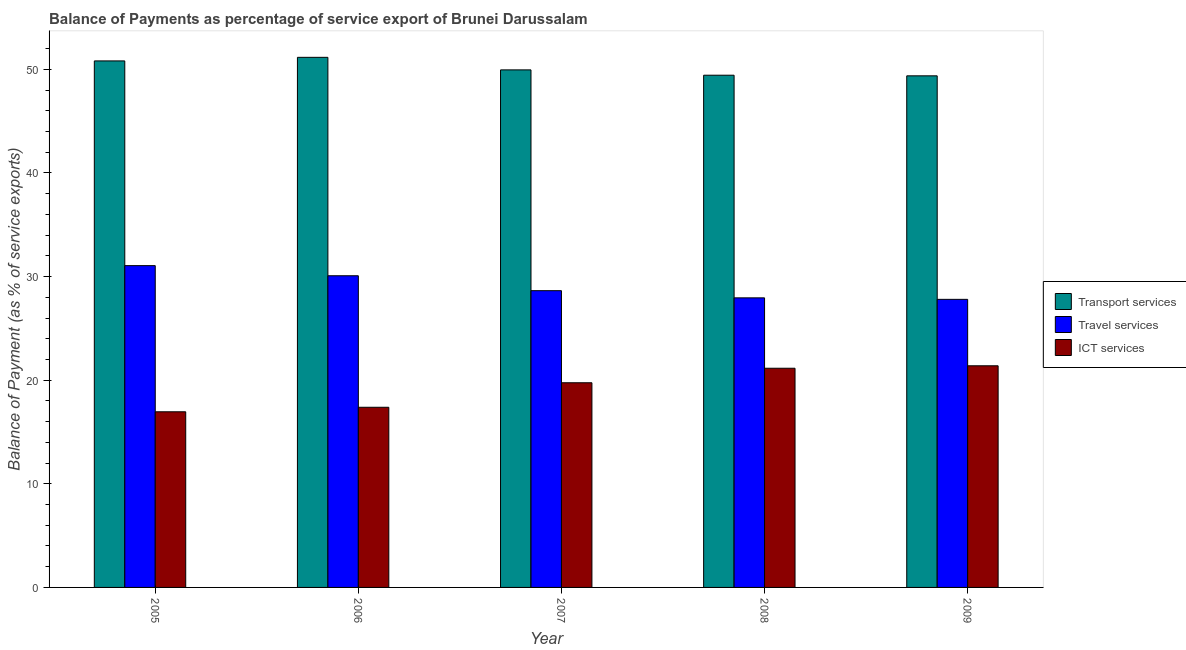Are the number of bars on each tick of the X-axis equal?
Provide a succinct answer. Yes. How many bars are there on the 4th tick from the left?
Make the answer very short. 3. How many bars are there on the 1st tick from the right?
Offer a very short reply. 3. What is the balance of payment of transport services in 2005?
Provide a short and direct response. 50.81. Across all years, what is the maximum balance of payment of travel services?
Offer a very short reply. 31.06. Across all years, what is the minimum balance of payment of travel services?
Provide a succinct answer. 27.8. What is the total balance of payment of ict services in the graph?
Your response must be concise. 96.64. What is the difference between the balance of payment of travel services in 2005 and that in 2007?
Ensure brevity in your answer.  2.42. What is the difference between the balance of payment of transport services in 2009 and the balance of payment of travel services in 2005?
Provide a short and direct response. -1.44. What is the average balance of payment of travel services per year?
Your response must be concise. 29.11. In the year 2005, what is the difference between the balance of payment of travel services and balance of payment of transport services?
Ensure brevity in your answer.  0. In how many years, is the balance of payment of travel services greater than 44 %?
Your answer should be compact. 0. What is the ratio of the balance of payment of ict services in 2005 to that in 2006?
Keep it short and to the point. 0.97. Is the balance of payment of ict services in 2005 less than that in 2008?
Your answer should be compact. Yes. Is the difference between the balance of payment of ict services in 2005 and 2006 greater than the difference between the balance of payment of transport services in 2005 and 2006?
Keep it short and to the point. No. What is the difference between the highest and the second highest balance of payment of travel services?
Keep it short and to the point. 0.98. What is the difference between the highest and the lowest balance of payment of travel services?
Make the answer very short. 3.25. What does the 1st bar from the left in 2005 represents?
Your answer should be very brief. Transport services. What does the 1st bar from the right in 2009 represents?
Your answer should be compact. ICT services. How many bars are there?
Your response must be concise. 15. What is the difference between two consecutive major ticks on the Y-axis?
Provide a succinct answer. 10. Where does the legend appear in the graph?
Offer a very short reply. Center right. How many legend labels are there?
Make the answer very short. 3. What is the title of the graph?
Your response must be concise. Balance of Payments as percentage of service export of Brunei Darussalam. Does "Natural Gas" appear as one of the legend labels in the graph?
Give a very brief answer. No. What is the label or title of the Y-axis?
Your answer should be compact. Balance of Payment (as % of service exports). What is the Balance of Payment (as % of service exports) in Transport services in 2005?
Your answer should be very brief. 50.81. What is the Balance of Payment (as % of service exports) of Travel services in 2005?
Offer a very short reply. 31.06. What is the Balance of Payment (as % of service exports) in ICT services in 2005?
Give a very brief answer. 16.95. What is the Balance of Payment (as % of service exports) of Transport services in 2006?
Provide a succinct answer. 51.16. What is the Balance of Payment (as % of service exports) of Travel services in 2006?
Your answer should be compact. 30.08. What is the Balance of Payment (as % of service exports) of ICT services in 2006?
Your answer should be compact. 17.39. What is the Balance of Payment (as % of service exports) in Transport services in 2007?
Your response must be concise. 49.95. What is the Balance of Payment (as % of service exports) in Travel services in 2007?
Make the answer very short. 28.64. What is the Balance of Payment (as % of service exports) of ICT services in 2007?
Give a very brief answer. 19.75. What is the Balance of Payment (as % of service exports) of Transport services in 2008?
Provide a succinct answer. 49.44. What is the Balance of Payment (as % of service exports) of Travel services in 2008?
Your answer should be very brief. 27.95. What is the Balance of Payment (as % of service exports) in ICT services in 2008?
Your answer should be compact. 21.15. What is the Balance of Payment (as % of service exports) in Transport services in 2009?
Your answer should be very brief. 49.38. What is the Balance of Payment (as % of service exports) of Travel services in 2009?
Offer a terse response. 27.8. What is the Balance of Payment (as % of service exports) of ICT services in 2009?
Give a very brief answer. 21.39. Across all years, what is the maximum Balance of Payment (as % of service exports) of Transport services?
Offer a very short reply. 51.16. Across all years, what is the maximum Balance of Payment (as % of service exports) of Travel services?
Make the answer very short. 31.06. Across all years, what is the maximum Balance of Payment (as % of service exports) of ICT services?
Offer a very short reply. 21.39. Across all years, what is the minimum Balance of Payment (as % of service exports) of Transport services?
Keep it short and to the point. 49.38. Across all years, what is the minimum Balance of Payment (as % of service exports) of Travel services?
Offer a very short reply. 27.8. Across all years, what is the minimum Balance of Payment (as % of service exports) of ICT services?
Ensure brevity in your answer.  16.95. What is the total Balance of Payment (as % of service exports) of Transport services in the graph?
Your answer should be very brief. 250.74. What is the total Balance of Payment (as % of service exports) of Travel services in the graph?
Provide a succinct answer. 145.53. What is the total Balance of Payment (as % of service exports) of ICT services in the graph?
Make the answer very short. 96.64. What is the difference between the Balance of Payment (as % of service exports) of Transport services in 2005 and that in 2006?
Offer a terse response. -0.35. What is the difference between the Balance of Payment (as % of service exports) of Travel services in 2005 and that in 2006?
Provide a succinct answer. 0.98. What is the difference between the Balance of Payment (as % of service exports) in ICT services in 2005 and that in 2006?
Provide a succinct answer. -0.44. What is the difference between the Balance of Payment (as % of service exports) in Transport services in 2005 and that in 2007?
Ensure brevity in your answer.  0.86. What is the difference between the Balance of Payment (as % of service exports) of Travel services in 2005 and that in 2007?
Provide a short and direct response. 2.42. What is the difference between the Balance of Payment (as % of service exports) in ICT services in 2005 and that in 2007?
Offer a very short reply. -2.8. What is the difference between the Balance of Payment (as % of service exports) in Transport services in 2005 and that in 2008?
Keep it short and to the point. 1.38. What is the difference between the Balance of Payment (as % of service exports) in Travel services in 2005 and that in 2008?
Offer a terse response. 3.11. What is the difference between the Balance of Payment (as % of service exports) of ICT services in 2005 and that in 2008?
Your answer should be very brief. -4.2. What is the difference between the Balance of Payment (as % of service exports) in Transport services in 2005 and that in 2009?
Provide a short and direct response. 1.44. What is the difference between the Balance of Payment (as % of service exports) in Travel services in 2005 and that in 2009?
Provide a short and direct response. 3.25. What is the difference between the Balance of Payment (as % of service exports) in ICT services in 2005 and that in 2009?
Your answer should be very brief. -4.44. What is the difference between the Balance of Payment (as % of service exports) in Transport services in 2006 and that in 2007?
Your answer should be compact. 1.21. What is the difference between the Balance of Payment (as % of service exports) in Travel services in 2006 and that in 2007?
Offer a terse response. 1.44. What is the difference between the Balance of Payment (as % of service exports) of ICT services in 2006 and that in 2007?
Your answer should be very brief. -2.37. What is the difference between the Balance of Payment (as % of service exports) in Transport services in 2006 and that in 2008?
Make the answer very short. 1.73. What is the difference between the Balance of Payment (as % of service exports) in Travel services in 2006 and that in 2008?
Ensure brevity in your answer.  2.13. What is the difference between the Balance of Payment (as % of service exports) of ICT services in 2006 and that in 2008?
Your answer should be very brief. -3.77. What is the difference between the Balance of Payment (as % of service exports) of Transport services in 2006 and that in 2009?
Provide a short and direct response. 1.79. What is the difference between the Balance of Payment (as % of service exports) in Travel services in 2006 and that in 2009?
Give a very brief answer. 2.28. What is the difference between the Balance of Payment (as % of service exports) in ICT services in 2006 and that in 2009?
Your response must be concise. -4. What is the difference between the Balance of Payment (as % of service exports) in Transport services in 2007 and that in 2008?
Provide a short and direct response. 0.51. What is the difference between the Balance of Payment (as % of service exports) of Travel services in 2007 and that in 2008?
Your answer should be very brief. 0.69. What is the difference between the Balance of Payment (as % of service exports) in ICT services in 2007 and that in 2008?
Offer a very short reply. -1.4. What is the difference between the Balance of Payment (as % of service exports) of Transport services in 2007 and that in 2009?
Give a very brief answer. 0.57. What is the difference between the Balance of Payment (as % of service exports) in Travel services in 2007 and that in 2009?
Provide a short and direct response. 0.84. What is the difference between the Balance of Payment (as % of service exports) in ICT services in 2007 and that in 2009?
Provide a succinct answer. -1.64. What is the difference between the Balance of Payment (as % of service exports) of Transport services in 2008 and that in 2009?
Give a very brief answer. 0.06. What is the difference between the Balance of Payment (as % of service exports) of Travel services in 2008 and that in 2009?
Offer a very short reply. 0.14. What is the difference between the Balance of Payment (as % of service exports) of ICT services in 2008 and that in 2009?
Offer a very short reply. -0.24. What is the difference between the Balance of Payment (as % of service exports) of Transport services in 2005 and the Balance of Payment (as % of service exports) of Travel services in 2006?
Ensure brevity in your answer.  20.73. What is the difference between the Balance of Payment (as % of service exports) in Transport services in 2005 and the Balance of Payment (as % of service exports) in ICT services in 2006?
Your response must be concise. 33.43. What is the difference between the Balance of Payment (as % of service exports) of Travel services in 2005 and the Balance of Payment (as % of service exports) of ICT services in 2006?
Provide a short and direct response. 13.67. What is the difference between the Balance of Payment (as % of service exports) in Transport services in 2005 and the Balance of Payment (as % of service exports) in Travel services in 2007?
Make the answer very short. 22.17. What is the difference between the Balance of Payment (as % of service exports) of Transport services in 2005 and the Balance of Payment (as % of service exports) of ICT services in 2007?
Your answer should be very brief. 31.06. What is the difference between the Balance of Payment (as % of service exports) in Travel services in 2005 and the Balance of Payment (as % of service exports) in ICT services in 2007?
Make the answer very short. 11.3. What is the difference between the Balance of Payment (as % of service exports) of Transport services in 2005 and the Balance of Payment (as % of service exports) of Travel services in 2008?
Your answer should be compact. 22.87. What is the difference between the Balance of Payment (as % of service exports) in Transport services in 2005 and the Balance of Payment (as % of service exports) in ICT services in 2008?
Your response must be concise. 29.66. What is the difference between the Balance of Payment (as % of service exports) of Travel services in 2005 and the Balance of Payment (as % of service exports) of ICT services in 2008?
Offer a terse response. 9.9. What is the difference between the Balance of Payment (as % of service exports) in Transport services in 2005 and the Balance of Payment (as % of service exports) in Travel services in 2009?
Your response must be concise. 23.01. What is the difference between the Balance of Payment (as % of service exports) of Transport services in 2005 and the Balance of Payment (as % of service exports) of ICT services in 2009?
Offer a terse response. 29.42. What is the difference between the Balance of Payment (as % of service exports) in Travel services in 2005 and the Balance of Payment (as % of service exports) in ICT services in 2009?
Offer a very short reply. 9.66. What is the difference between the Balance of Payment (as % of service exports) of Transport services in 2006 and the Balance of Payment (as % of service exports) of Travel services in 2007?
Your answer should be compact. 22.52. What is the difference between the Balance of Payment (as % of service exports) in Transport services in 2006 and the Balance of Payment (as % of service exports) in ICT services in 2007?
Give a very brief answer. 31.41. What is the difference between the Balance of Payment (as % of service exports) of Travel services in 2006 and the Balance of Payment (as % of service exports) of ICT services in 2007?
Ensure brevity in your answer.  10.33. What is the difference between the Balance of Payment (as % of service exports) in Transport services in 2006 and the Balance of Payment (as % of service exports) in Travel services in 2008?
Give a very brief answer. 23.21. What is the difference between the Balance of Payment (as % of service exports) in Transport services in 2006 and the Balance of Payment (as % of service exports) in ICT services in 2008?
Keep it short and to the point. 30.01. What is the difference between the Balance of Payment (as % of service exports) of Travel services in 2006 and the Balance of Payment (as % of service exports) of ICT services in 2008?
Ensure brevity in your answer.  8.93. What is the difference between the Balance of Payment (as % of service exports) of Transport services in 2006 and the Balance of Payment (as % of service exports) of Travel services in 2009?
Provide a short and direct response. 23.36. What is the difference between the Balance of Payment (as % of service exports) of Transport services in 2006 and the Balance of Payment (as % of service exports) of ICT services in 2009?
Ensure brevity in your answer.  29.77. What is the difference between the Balance of Payment (as % of service exports) of Travel services in 2006 and the Balance of Payment (as % of service exports) of ICT services in 2009?
Provide a short and direct response. 8.69. What is the difference between the Balance of Payment (as % of service exports) in Transport services in 2007 and the Balance of Payment (as % of service exports) in Travel services in 2008?
Ensure brevity in your answer.  22. What is the difference between the Balance of Payment (as % of service exports) in Transport services in 2007 and the Balance of Payment (as % of service exports) in ICT services in 2008?
Provide a short and direct response. 28.8. What is the difference between the Balance of Payment (as % of service exports) of Travel services in 2007 and the Balance of Payment (as % of service exports) of ICT services in 2008?
Give a very brief answer. 7.49. What is the difference between the Balance of Payment (as % of service exports) in Transport services in 2007 and the Balance of Payment (as % of service exports) in Travel services in 2009?
Provide a short and direct response. 22.15. What is the difference between the Balance of Payment (as % of service exports) of Transport services in 2007 and the Balance of Payment (as % of service exports) of ICT services in 2009?
Provide a succinct answer. 28.56. What is the difference between the Balance of Payment (as % of service exports) of Travel services in 2007 and the Balance of Payment (as % of service exports) of ICT services in 2009?
Keep it short and to the point. 7.25. What is the difference between the Balance of Payment (as % of service exports) of Transport services in 2008 and the Balance of Payment (as % of service exports) of Travel services in 2009?
Provide a short and direct response. 21.63. What is the difference between the Balance of Payment (as % of service exports) in Transport services in 2008 and the Balance of Payment (as % of service exports) in ICT services in 2009?
Your answer should be compact. 28.04. What is the difference between the Balance of Payment (as % of service exports) in Travel services in 2008 and the Balance of Payment (as % of service exports) in ICT services in 2009?
Offer a very short reply. 6.56. What is the average Balance of Payment (as % of service exports) in Transport services per year?
Offer a very short reply. 50.15. What is the average Balance of Payment (as % of service exports) of Travel services per year?
Give a very brief answer. 29.11. What is the average Balance of Payment (as % of service exports) in ICT services per year?
Your answer should be very brief. 19.33. In the year 2005, what is the difference between the Balance of Payment (as % of service exports) in Transport services and Balance of Payment (as % of service exports) in Travel services?
Your response must be concise. 19.76. In the year 2005, what is the difference between the Balance of Payment (as % of service exports) in Transport services and Balance of Payment (as % of service exports) in ICT services?
Your answer should be very brief. 33.86. In the year 2005, what is the difference between the Balance of Payment (as % of service exports) in Travel services and Balance of Payment (as % of service exports) in ICT services?
Your answer should be compact. 14.11. In the year 2006, what is the difference between the Balance of Payment (as % of service exports) in Transport services and Balance of Payment (as % of service exports) in Travel services?
Your answer should be very brief. 21.08. In the year 2006, what is the difference between the Balance of Payment (as % of service exports) in Transport services and Balance of Payment (as % of service exports) in ICT services?
Your answer should be very brief. 33.77. In the year 2006, what is the difference between the Balance of Payment (as % of service exports) in Travel services and Balance of Payment (as % of service exports) in ICT services?
Offer a very short reply. 12.69. In the year 2007, what is the difference between the Balance of Payment (as % of service exports) of Transport services and Balance of Payment (as % of service exports) of Travel services?
Provide a short and direct response. 21.31. In the year 2007, what is the difference between the Balance of Payment (as % of service exports) in Transport services and Balance of Payment (as % of service exports) in ICT services?
Your answer should be very brief. 30.2. In the year 2007, what is the difference between the Balance of Payment (as % of service exports) in Travel services and Balance of Payment (as % of service exports) in ICT services?
Your response must be concise. 8.89. In the year 2008, what is the difference between the Balance of Payment (as % of service exports) of Transport services and Balance of Payment (as % of service exports) of Travel services?
Make the answer very short. 21.49. In the year 2008, what is the difference between the Balance of Payment (as % of service exports) of Transport services and Balance of Payment (as % of service exports) of ICT services?
Provide a short and direct response. 28.28. In the year 2008, what is the difference between the Balance of Payment (as % of service exports) of Travel services and Balance of Payment (as % of service exports) of ICT services?
Offer a terse response. 6.79. In the year 2009, what is the difference between the Balance of Payment (as % of service exports) in Transport services and Balance of Payment (as % of service exports) in Travel services?
Ensure brevity in your answer.  21.57. In the year 2009, what is the difference between the Balance of Payment (as % of service exports) in Transport services and Balance of Payment (as % of service exports) in ICT services?
Your answer should be very brief. 27.98. In the year 2009, what is the difference between the Balance of Payment (as % of service exports) of Travel services and Balance of Payment (as % of service exports) of ICT services?
Your answer should be very brief. 6.41. What is the ratio of the Balance of Payment (as % of service exports) in Travel services in 2005 to that in 2006?
Provide a short and direct response. 1.03. What is the ratio of the Balance of Payment (as % of service exports) of ICT services in 2005 to that in 2006?
Your response must be concise. 0.97. What is the ratio of the Balance of Payment (as % of service exports) in Transport services in 2005 to that in 2007?
Your answer should be compact. 1.02. What is the ratio of the Balance of Payment (as % of service exports) of Travel services in 2005 to that in 2007?
Give a very brief answer. 1.08. What is the ratio of the Balance of Payment (as % of service exports) of ICT services in 2005 to that in 2007?
Ensure brevity in your answer.  0.86. What is the ratio of the Balance of Payment (as % of service exports) in Transport services in 2005 to that in 2008?
Your response must be concise. 1.03. What is the ratio of the Balance of Payment (as % of service exports) in Travel services in 2005 to that in 2008?
Offer a very short reply. 1.11. What is the ratio of the Balance of Payment (as % of service exports) in ICT services in 2005 to that in 2008?
Your answer should be compact. 0.8. What is the ratio of the Balance of Payment (as % of service exports) of Transport services in 2005 to that in 2009?
Provide a short and direct response. 1.03. What is the ratio of the Balance of Payment (as % of service exports) in Travel services in 2005 to that in 2009?
Keep it short and to the point. 1.12. What is the ratio of the Balance of Payment (as % of service exports) in ICT services in 2005 to that in 2009?
Give a very brief answer. 0.79. What is the ratio of the Balance of Payment (as % of service exports) in Transport services in 2006 to that in 2007?
Your answer should be compact. 1.02. What is the ratio of the Balance of Payment (as % of service exports) in Travel services in 2006 to that in 2007?
Ensure brevity in your answer.  1.05. What is the ratio of the Balance of Payment (as % of service exports) of ICT services in 2006 to that in 2007?
Provide a succinct answer. 0.88. What is the ratio of the Balance of Payment (as % of service exports) of Transport services in 2006 to that in 2008?
Ensure brevity in your answer.  1.03. What is the ratio of the Balance of Payment (as % of service exports) in Travel services in 2006 to that in 2008?
Ensure brevity in your answer.  1.08. What is the ratio of the Balance of Payment (as % of service exports) in ICT services in 2006 to that in 2008?
Offer a very short reply. 0.82. What is the ratio of the Balance of Payment (as % of service exports) in Transport services in 2006 to that in 2009?
Provide a succinct answer. 1.04. What is the ratio of the Balance of Payment (as % of service exports) in Travel services in 2006 to that in 2009?
Your response must be concise. 1.08. What is the ratio of the Balance of Payment (as % of service exports) in ICT services in 2006 to that in 2009?
Ensure brevity in your answer.  0.81. What is the ratio of the Balance of Payment (as % of service exports) in Transport services in 2007 to that in 2008?
Keep it short and to the point. 1.01. What is the ratio of the Balance of Payment (as % of service exports) in Travel services in 2007 to that in 2008?
Provide a succinct answer. 1.02. What is the ratio of the Balance of Payment (as % of service exports) in ICT services in 2007 to that in 2008?
Your response must be concise. 0.93. What is the ratio of the Balance of Payment (as % of service exports) in Transport services in 2007 to that in 2009?
Ensure brevity in your answer.  1.01. What is the ratio of the Balance of Payment (as % of service exports) of Travel services in 2007 to that in 2009?
Keep it short and to the point. 1.03. What is the ratio of the Balance of Payment (as % of service exports) in ICT services in 2007 to that in 2009?
Make the answer very short. 0.92. What is the ratio of the Balance of Payment (as % of service exports) of Transport services in 2008 to that in 2009?
Your response must be concise. 1. What is the ratio of the Balance of Payment (as % of service exports) in Travel services in 2008 to that in 2009?
Offer a terse response. 1.01. What is the ratio of the Balance of Payment (as % of service exports) of ICT services in 2008 to that in 2009?
Your answer should be very brief. 0.99. What is the difference between the highest and the second highest Balance of Payment (as % of service exports) of Transport services?
Provide a short and direct response. 0.35. What is the difference between the highest and the second highest Balance of Payment (as % of service exports) in Travel services?
Offer a terse response. 0.98. What is the difference between the highest and the second highest Balance of Payment (as % of service exports) of ICT services?
Offer a terse response. 0.24. What is the difference between the highest and the lowest Balance of Payment (as % of service exports) in Transport services?
Provide a short and direct response. 1.79. What is the difference between the highest and the lowest Balance of Payment (as % of service exports) in Travel services?
Provide a short and direct response. 3.25. What is the difference between the highest and the lowest Balance of Payment (as % of service exports) in ICT services?
Keep it short and to the point. 4.44. 